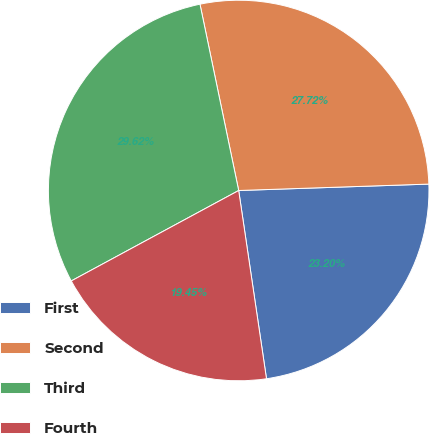<chart> <loc_0><loc_0><loc_500><loc_500><pie_chart><fcel>First<fcel>Second<fcel>Third<fcel>Fourth<nl><fcel>23.2%<fcel>27.72%<fcel>29.62%<fcel>19.45%<nl></chart> 